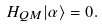<formula> <loc_0><loc_0><loc_500><loc_500>H _ { Q M } | \alpha \rangle = 0 .</formula> 